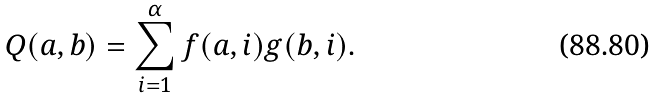Convert formula to latex. <formula><loc_0><loc_0><loc_500><loc_500>Q ( a , b ) = \sum _ { i = 1 } ^ { \alpha } f ( a , i ) g ( b , i ) .</formula> 